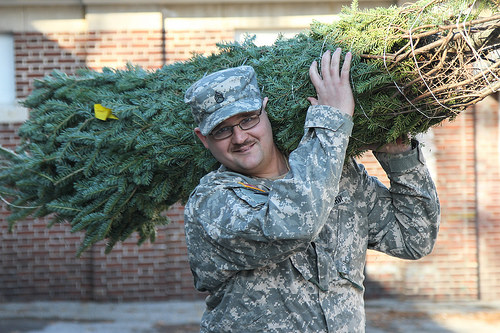<image>
Can you confirm if the soldier is in the trees? No. The soldier is not contained within the trees. These objects have a different spatial relationship. 